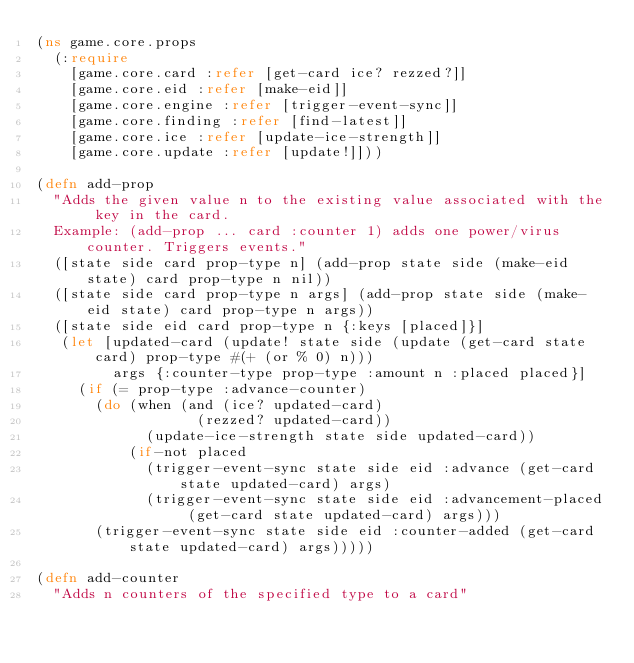Convert code to text. <code><loc_0><loc_0><loc_500><loc_500><_Clojure_>(ns game.core.props
  (:require
    [game.core.card :refer [get-card ice? rezzed?]]
    [game.core.eid :refer [make-eid]]
    [game.core.engine :refer [trigger-event-sync]]
    [game.core.finding :refer [find-latest]]
    [game.core.ice :refer [update-ice-strength]]
    [game.core.update :refer [update!]]))

(defn add-prop
  "Adds the given value n to the existing value associated with the key in the card.
  Example: (add-prop ... card :counter 1) adds one power/virus counter. Triggers events."
  ([state side card prop-type n] (add-prop state side (make-eid state) card prop-type n nil))
  ([state side card prop-type n args] (add-prop state side (make-eid state) card prop-type n args))
  ([state side eid card prop-type n {:keys [placed]}]
   (let [updated-card (update! state side (update (get-card state card) prop-type #(+ (or % 0) n)))
         args {:counter-type prop-type :amount n :placed placed}]
     (if (= prop-type :advance-counter)
       (do (when (and (ice? updated-card)
                   (rezzed? updated-card))
             (update-ice-strength state side updated-card))
           (if-not placed
             (trigger-event-sync state side eid :advance (get-card state updated-card) args)
             (trigger-event-sync state side eid :advancement-placed (get-card state updated-card) args)))
       (trigger-event-sync state side eid :counter-added (get-card state updated-card) args)))))

(defn add-counter
  "Adds n counters of the specified type to a card"</code> 